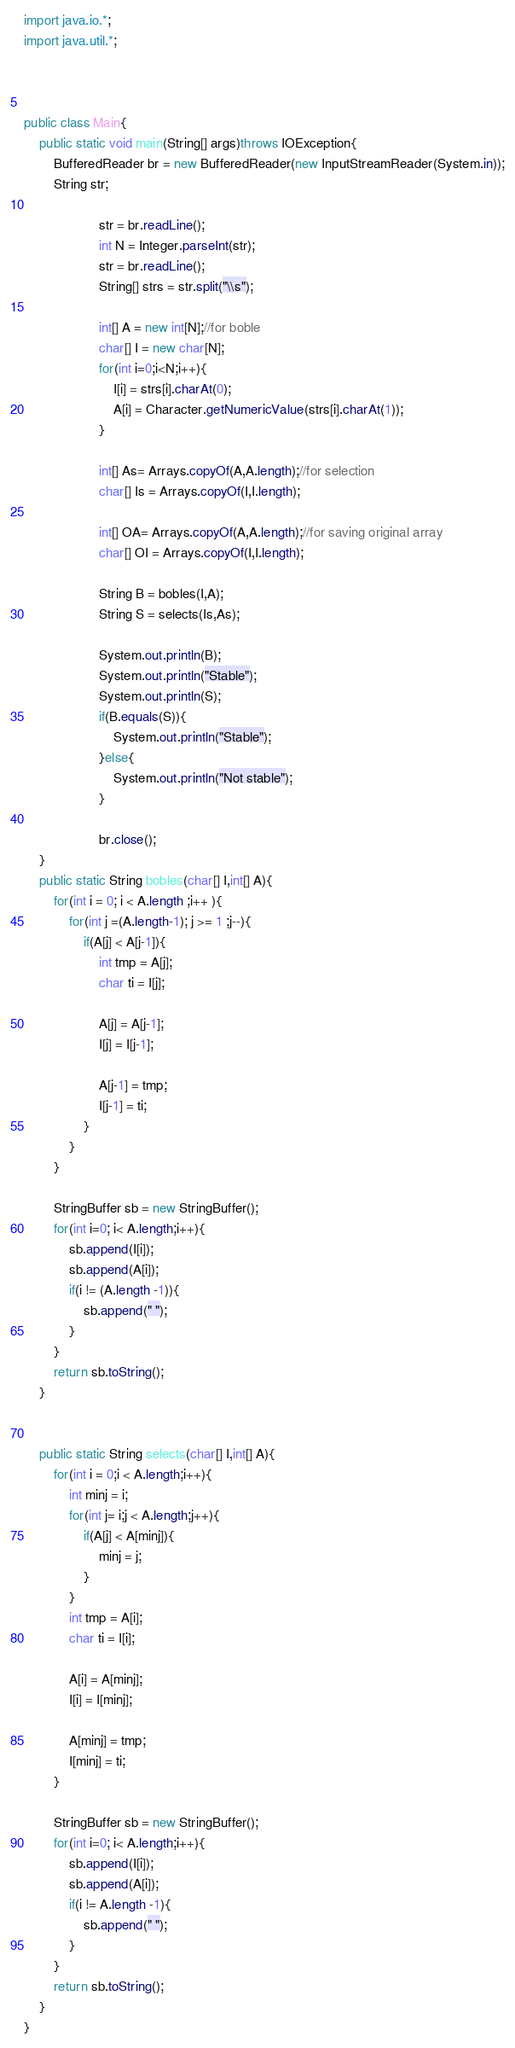Convert code to text. <code><loc_0><loc_0><loc_500><loc_500><_Java_>import java.io.*;
import java.util.*;



public class Main{
    public static void main(String[] args)throws IOException{
        BufferedReader br = new BufferedReader(new InputStreamReader(System.in));
        String str;
                    
                    str = br.readLine();
                    int N = Integer.parseInt(str);
                    str = br.readLine();
                    String[] strs = str.split("\\s");

                    int[] A = new int[N];//for boble
                    char[] I = new char[N];
                    for(int i=0;i<N;i++){
                        I[i] = strs[i].charAt(0);
                        A[i] = Character.getNumericValue(strs[i].charAt(1));
                    }

                    int[] As= Arrays.copyOf(A,A.length);//for selection
                    char[] Is = Arrays.copyOf(I,I.length);
                    
                    int[] OA= Arrays.copyOf(A,A.length);//for saving original array
                    char[] OI = Arrays.copyOf(I,I.length); 

                    String B = bobles(I,A);
                    String S = selects(Is,As);

                    System.out.println(B);
                    System.out.println("Stable");
                    System.out.println(S);
                    if(B.equals(S)){
                        System.out.println("Stable");
                    }else{
                        System.out.println("Not stable");
                    }
                    
                    br.close();
    }
    public static String bobles(char[] I,int[] A){
        for(int i = 0; i < A.length ;i++ ){
            for(int j =(A.length-1); j >= 1 ;j--){
                if(A[j] < A[j-1]){
                    int tmp = A[j];
                    char ti = I[j];

                    A[j] = A[j-1];
                    I[j] = I[j-1];

                    A[j-1] = tmp;
                    I[j-1] = ti;
                }
            }
        }

        StringBuffer sb = new StringBuffer();
        for(int i=0; i< A.length;i++){
            sb.append(I[i]);
            sb.append(A[i]);
            if(i != (A.length -1)){
                sb.append(" ");
            }
        }
        return sb.toString();
    }


    public static String selects(char[] I,int[] A){
        for(int i = 0;i < A.length;i++){
            int minj = i;
            for(int j= i;j < A.length;j++){
                if(A[j] < A[minj]){
                    minj = j;
                }
            }
            int tmp = A[i];
            char ti = I[i];

            A[i] = A[minj];
            I[i] = I[minj];

            A[minj] = tmp;
            I[minj] = ti;
        }

        StringBuffer sb = new StringBuffer();
        for(int i=0; i< A.length;i++){
            sb.append(I[i]);
            sb.append(A[i]);
            if(i != A.length -1){
                sb.append(" ");
            }
        }
        return sb.toString();
    }
}
</code> 